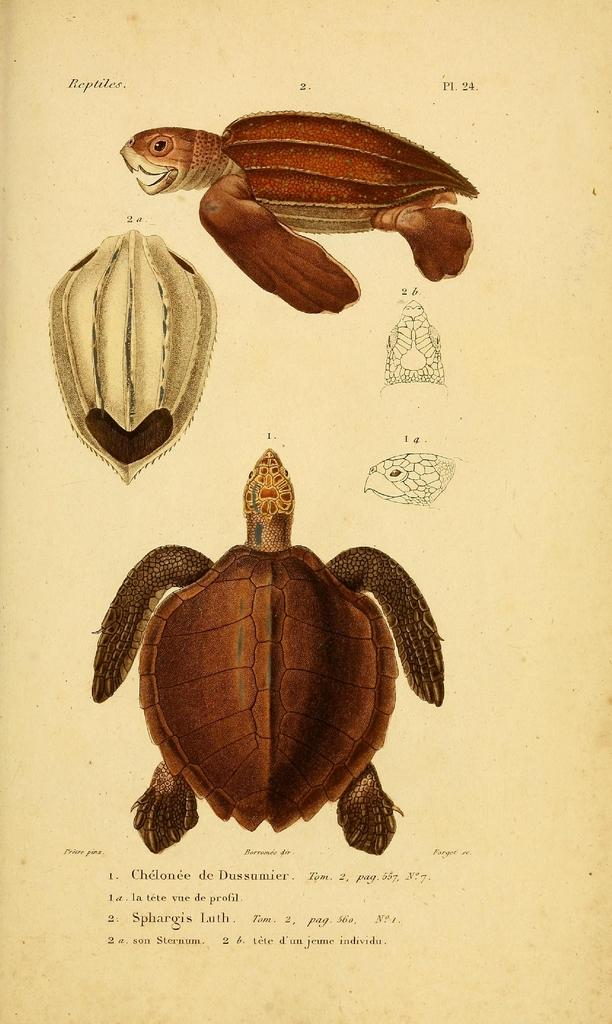What is the main subject of the paper in the image? The main subject of the paper in the image are two images of tortoises. Are there any other images on the paper besides the tortoises? Yes, there are other images on the paper. Can you describe the text at the bottom of the paper? Unfortunately, the text at the bottom of the paper cannot be read or described from the image alone. What is the purpose of the paper in the image? Based on the images and text, it appears to be a document or illustration related to tortoises. What type of toys can be seen in the image? There are no toys present in the image; it contains a paper with images and text. Can you see a mountain in the image? There is no mountain visible in the image; it features a paper with various images and text. 